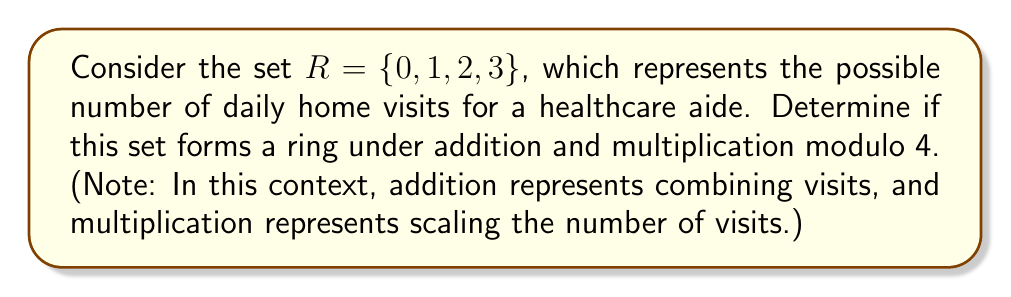Provide a solution to this math problem. To determine if the set $R = \{0, 1, 2, 3\}$ forms a ring under addition and multiplication modulo 4, we need to check if it satisfies all the ring axioms:

1. Closure under addition and multiplication:
   For all $a, b \in R$, $a + b \in R$ and $a \cdot b \in R$
   
   Addition modulo 4:
   $$\begin{array}{c|cccc}
   + & 0 & 1 & 2 & 3 \\
   \hline
   0 & 0 & 1 & 2 & 3 \\
   1 & 1 & 2 & 3 & 0 \\
   2 & 2 & 3 & 0 & 1 \\
   3 & 3 & 0 & 1 & 2
   \end{array}$$

   Multiplication modulo 4:
   $$\begin{array}{c|cccc}
   \cdot & 0 & 1 & 2 & 3 \\
   \hline
   0 & 0 & 0 & 0 & 0 \\
   1 & 0 & 1 & 2 & 3 \\
   2 & 0 & 2 & 0 & 2 \\
   3 & 0 & 3 & 2 & 1
   \end{array}$$

   All results are in $R$, so closure is satisfied.

2. Associativity of addition and multiplication:
   $(a + b) + c = a + (b + c)$ and $(a \cdot b) \cdot c = a \cdot (b \cdot c)$ for all $a, b, c \in R$
   This property holds for modular arithmetic.

3. Commutativity of addition:
   $a + b = b + a$ for all $a, b \in R$
   This property holds for modular addition.

4. Existence of additive identity:
   There exists $0 \in R$ such that $a + 0 = a$ for all $a \in R$
   The element 0 serves as the additive identity.

5. Existence of additive inverse:
   For each $a \in R$, there exists $-a \in R$ such that $a + (-a) = 0$
   0 + 0 = 0, 1 + 3 = 0, 2 + 2 = 0, 3 + 1 = 0 (all modulo 4)

6. Distributivity of multiplication over addition:
   $a \cdot (b + c) = (a \cdot b) + (a \cdot c)$ for all $a, b, c \in R$
   This property holds for modular arithmetic.

Since all ring axioms are satisfied, $R = \{0, 1, 2, 3\}$ forms a ring under addition and multiplication modulo 4.
Answer: Yes, the set $R = \{0, 1, 2, 3\}$ forms a ring under addition and multiplication modulo 4. 